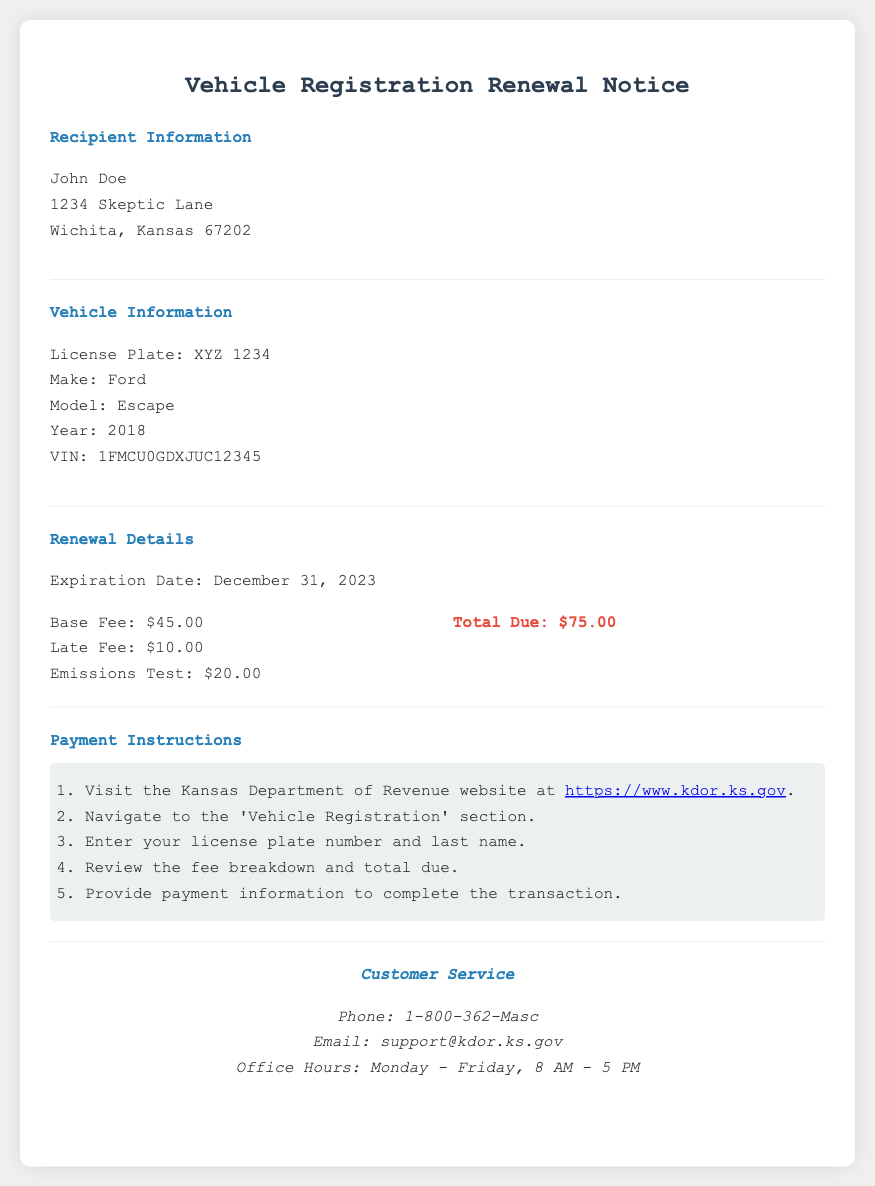What is the expiration date of the vehicle registration? The expiration date is listed in the renewal details section of the document.
Answer: December 31, 2023 What is the base fee for the renewal? The base fee is specified under the fee breakdown section of the document.
Answer: $45.00 Who is the recipient of the notice? The recipient's name is given at the beginning of the document in the recipient information section.
Answer: John Doe What is the total amount due for the vehicle registration? The total due is calculated by adding all the fees listed in the fee breakdown.
Answer: $75.00 How many steps are listed in the payment instructions? The instructions are provided in an ordered list format, indicating the number of steps to complete the payment.
Answer: 5 steps What make and model is the vehicle mentioned in the document? The make and model of the vehicle are found in the vehicle information section.
Answer: Ford Escape What is the late fee for the registration renewal? The late fee is specified in the fee breakdown section.
Answer: $10.00 What is the customer service phone number? The phone number for customer service is provided in the customer service section.
Answer: 1-800-362-Masc 